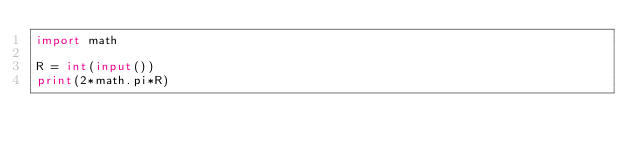<code> <loc_0><loc_0><loc_500><loc_500><_Python_>import math

R = int(input())
print(2*math.pi*R)
</code> 